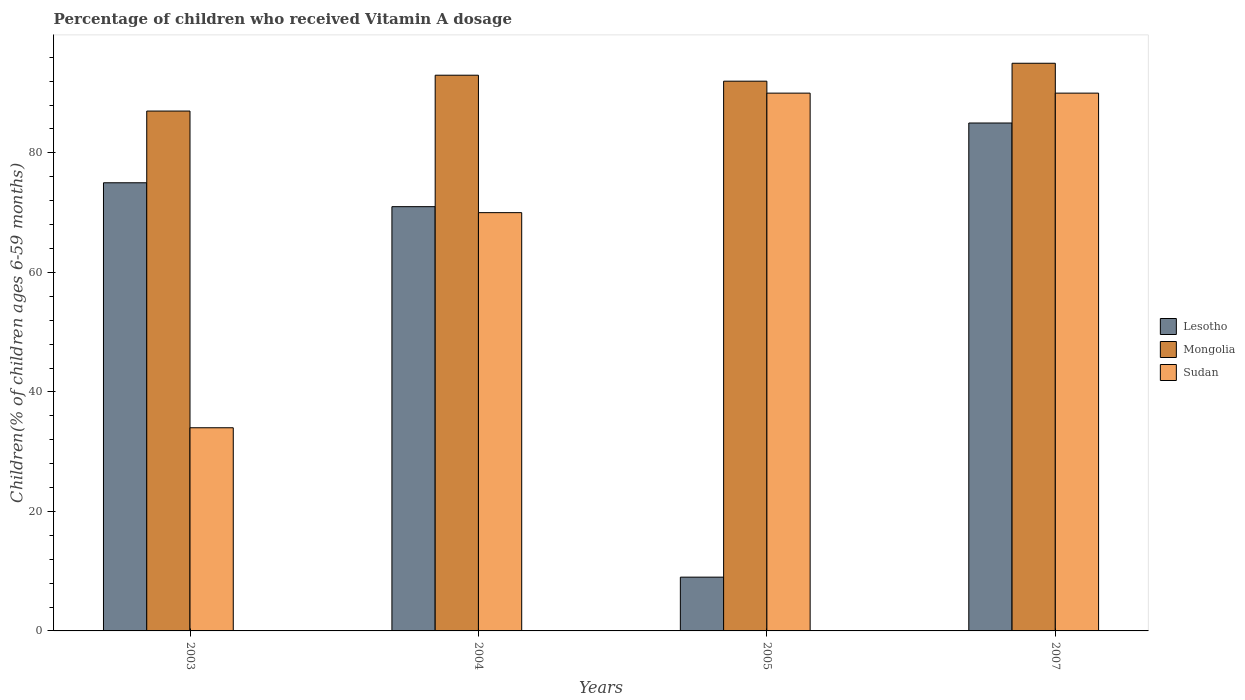How many groups of bars are there?
Your answer should be very brief. 4. Are the number of bars per tick equal to the number of legend labels?
Give a very brief answer. Yes. How many bars are there on the 3rd tick from the right?
Offer a very short reply. 3. In how many cases, is the number of bars for a given year not equal to the number of legend labels?
Provide a short and direct response. 0. Across all years, what is the maximum percentage of children who received Vitamin A dosage in Mongolia?
Give a very brief answer. 95. In which year was the percentage of children who received Vitamin A dosage in Sudan minimum?
Provide a succinct answer. 2003. What is the total percentage of children who received Vitamin A dosage in Mongolia in the graph?
Provide a short and direct response. 367. What is the average percentage of children who received Vitamin A dosage in Sudan per year?
Provide a succinct answer. 71. In the year 2003, what is the difference between the percentage of children who received Vitamin A dosage in Mongolia and percentage of children who received Vitamin A dosage in Lesotho?
Provide a succinct answer. 12. In how many years, is the percentage of children who received Vitamin A dosage in Mongolia greater than 48 %?
Your answer should be very brief. 4. What is the ratio of the percentage of children who received Vitamin A dosage in Mongolia in 2003 to that in 2005?
Offer a terse response. 0.95. What is the difference between the highest and the lowest percentage of children who received Vitamin A dosage in Mongolia?
Keep it short and to the point. 8. Is the sum of the percentage of children who received Vitamin A dosage in Lesotho in 2004 and 2007 greater than the maximum percentage of children who received Vitamin A dosage in Mongolia across all years?
Ensure brevity in your answer.  Yes. What does the 2nd bar from the left in 2007 represents?
Make the answer very short. Mongolia. What does the 1st bar from the right in 2005 represents?
Make the answer very short. Sudan. Is it the case that in every year, the sum of the percentage of children who received Vitamin A dosage in Sudan and percentage of children who received Vitamin A dosage in Mongolia is greater than the percentage of children who received Vitamin A dosage in Lesotho?
Your answer should be compact. Yes. Are the values on the major ticks of Y-axis written in scientific E-notation?
Provide a succinct answer. No. Does the graph contain any zero values?
Your answer should be very brief. No. Does the graph contain grids?
Give a very brief answer. No. Where does the legend appear in the graph?
Provide a short and direct response. Center right. How are the legend labels stacked?
Keep it short and to the point. Vertical. What is the title of the graph?
Your response must be concise. Percentage of children who received Vitamin A dosage. What is the label or title of the Y-axis?
Offer a terse response. Children(% of children ages 6-59 months). What is the Children(% of children ages 6-59 months) in Mongolia in 2003?
Keep it short and to the point. 87. What is the Children(% of children ages 6-59 months) in Sudan in 2003?
Provide a succinct answer. 34. What is the Children(% of children ages 6-59 months) of Mongolia in 2004?
Ensure brevity in your answer.  93. What is the Children(% of children ages 6-59 months) in Sudan in 2004?
Make the answer very short. 70. What is the Children(% of children ages 6-59 months) in Lesotho in 2005?
Offer a very short reply. 9. What is the Children(% of children ages 6-59 months) of Mongolia in 2005?
Keep it short and to the point. 92. What is the Children(% of children ages 6-59 months) in Sudan in 2005?
Ensure brevity in your answer.  90. What is the Children(% of children ages 6-59 months) of Lesotho in 2007?
Offer a very short reply. 85. What is the Children(% of children ages 6-59 months) in Mongolia in 2007?
Ensure brevity in your answer.  95. What is the Children(% of children ages 6-59 months) of Sudan in 2007?
Provide a short and direct response. 90. Across all years, what is the maximum Children(% of children ages 6-59 months) in Lesotho?
Your answer should be very brief. 85. Across all years, what is the maximum Children(% of children ages 6-59 months) of Mongolia?
Your answer should be very brief. 95. Across all years, what is the maximum Children(% of children ages 6-59 months) in Sudan?
Your response must be concise. 90. Across all years, what is the minimum Children(% of children ages 6-59 months) of Lesotho?
Provide a short and direct response. 9. Across all years, what is the minimum Children(% of children ages 6-59 months) of Mongolia?
Your answer should be very brief. 87. What is the total Children(% of children ages 6-59 months) in Lesotho in the graph?
Offer a terse response. 240. What is the total Children(% of children ages 6-59 months) in Mongolia in the graph?
Your answer should be very brief. 367. What is the total Children(% of children ages 6-59 months) of Sudan in the graph?
Your answer should be compact. 284. What is the difference between the Children(% of children ages 6-59 months) of Mongolia in 2003 and that in 2004?
Provide a succinct answer. -6. What is the difference between the Children(% of children ages 6-59 months) of Sudan in 2003 and that in 2004?
Make the answer very short. -36. What is the difference between the Children(% of children ages 6-59 months) in Sudan in 2003 and that in 2005?
Provide a short and direct response. -56. What is the difference between the Children(% of children ages 6-59 months) of Sudan in 2003 and that in 2007?
Provide a succinct answer. -56. What is the difference between the Children(% of children ages 6-59 months) in Lesotho in 2004 and that in 2005?
Give a very brief answer. 62. What is the difference between the Children(% of children ages 6-59 months) in Sudan in 2004 and that in 2005?
Offer a very short reply. -20. What is the difference between the Children(% of children ages 6-59 months) in Lesotho in 2004 and that in 2007?
Offer a terse response. -14. What is the difference between the Children(% of children ages 6-59 months) in Mongolia in 2004 and that in 2007?
Give a very brief answer. -2. What is the difference between the Children(% of children ages 6-59 months) in Sudan in 2004 and that in 2007?
Offer a very short reply. -20. What is the difference between the Children(% of children ages 6-59 months) of Lesotho in 2005 and that in 2007?
Your answer should be compact. -76. What is the difference between the Children(% of children ages 6-59 months) of Lesotho in 2003 and the Children(% of children ages 6-59 months) of Sudan in 2004?
Your response must be concise. 5. What is the difference between the Children(% of children ages 6-59 months) of Lesotho in 2003 and the Children(% of children ages 6-59 months) of Mongolia in 2005?
Your answer should be very brief. -17. What is the difference between the Children(% of children ages 6-59 months) of Mongolia in 2003 and the Children(% of children ages 6-59 months) of Sudan in 2005?
Ensure brevity in your answer.  -3. What is the difference between the Children(% of children ages 6-59 months) of Lesotho in 2003 and the Children(% of children ages 6-59 months) of Mongolia in 2007?
Your answer should be compact. -20. What is the difference between the Children(% of children ages 6-59 months) in Lesotho in 2003 and the Children(% of children ages 6-59 months) in Sudan in 2007?
Ensure brevity in your answer.  -15. What is the difference between the Children(% of children ages 6-59 months) in Mongolia in 2003 and the Children(% of children ages 6-59 months) in Sudan in 2007?
Offer a terse response. -3. What is the difference between the Children(% of children ages 6-59 months) in Lesotho in 2005 and the Children(% of children ages 6-59 months) in Mongolia in 2007?
Ensure brevity in your answer.  -86. What is the difference between the Children(% of children ages 6-59 months) in Lesotho in 2005 and the Children(% of children ages 6-59 months) in Sudan in 2007?
Make the answer very short. -81. What is the difference between the Children(% of children ages 6-59 months) of Mongolia in 2005 and the Children(% of children ages 6-59 months) of Sudan in 2007?
Provide a short and direct response. 2. What is the average Children(% of children ages 6-59 months) of Mongolia per year?
Make the answer very short. 91.75. In the year 2003, what is the difference between the Children(% of children ages 6-59 months) of Lesotho and Children(% of children ages 6-59 months) of Mongolia?
Keep it short and to the point. -12. In the year 2003, what is the difference between the Children(% of children ages 6-59 months) of Lesotho and Children(% of children ages 6-59 months) of Sudan?
Ensure brevity in your answer.  41. In the year 2004, what is the difference between the Children(% of children ages 6-59 months) in Lesotho and Children(% of children ages 6-59 months) in Sudan?
Your answer should be compact. 1. In the year 2004, what is the difference between the Children(% of children ages 6-59 months) in Mongolia and Children(% of children ages 6-59 months) in Sudan?
Give a very brief answer. 23. In the year 2005, what is the difference between the Children(% of children ages 6-59 months) of Lesotho and Children(% of children ages 6-59 months) of Mongolia?
Your answer should be very brief. -83. In the year 2005, what is the difference between the Children(% of children ages 6-59 months) of Lesotho and Children(% of children ages 6-59 months) of Sudan?
Your response must be concise. -81. What is the ratio of the Children(% of children ages 6-59 months) in Lesotho in 2003 to that in 2004?
Give a very brief answer. 1.06. What is the ratio of the Children(% of children ages 6-59 months) of Mongolia in 2003 to that in 2004?
Your answer should be very brief. 0.94. What is the ratio of the Children(% of children ages 6-59 months) of Sudan in 2003 to that in 2004?
Give a very brief answer. 0.49. What is the ratio of the Children(% of children ages 6-59 months) of Lesotho in 2003 to that in 2005?
Keep it short and to the point. 8.33. What is the ratio of the Children(% of children ages 6-59 months) in Mongolia in 2003 to that in 2005?
Your answer should be very brief. 0.95. What is the ratio of the Children(% of children ages 6-59 months) in Sudan in 2003 to that in 2005?
Offer a terse response. 0.38. What is the ratio of the Children(% of children ages 6-59 months) of Lesotho in 2003 to that in 2007?
Offer a terse response. 0.88. What is the ratio of the Children(% of children ages 6-59 months) in Mongolia in 2003 to that in 2007?
Give a very brief answer. 0.92. What is the ratio of the Children(% of children ages 6-59 months) in Sudan in 2003 to that in 2007?
Your answer should be compact. 0.38. What is the ratio of the Children(% of children ages 6-59 months) in Lesotho in 2004 to that in 2005?
Make the answer very short. 7.89. What is the ratio of the Children(% of children ages 6-59 months) of Mongolia in 2004 to that in 2005?
Make the answer very short. 1.01. What is the ratio of the Children(% of children ages 6-59 months) in Lesotho in 2004 to that in 2007?
Provide a succinct answer. 0.84. What is the ratio of the Children(% of children ages 6-59 months) in Mongolia in 2004 to that in 2007?
Keep it short and to the point. 0.98. What is the ratio of the Children(% of children ages 6-59 months) in Lesotho in 2005 to that in 2007?
Provide a succinct answer. 0.11. What is the ratio of the Children(% of children ages 6-59 months) in Mongolia in 2005 to that in 2007?
Provide a succinct answer. 0.97. What is the difference between the highest and the second highest Children(% of children ages 6-59 months) of Mongolia?
Offer a terse response. 2. What is the difference between the highest and the lowest Children(% of children ages 6-59 months) of Lesotho?
Provide a short and direct response. 76. 